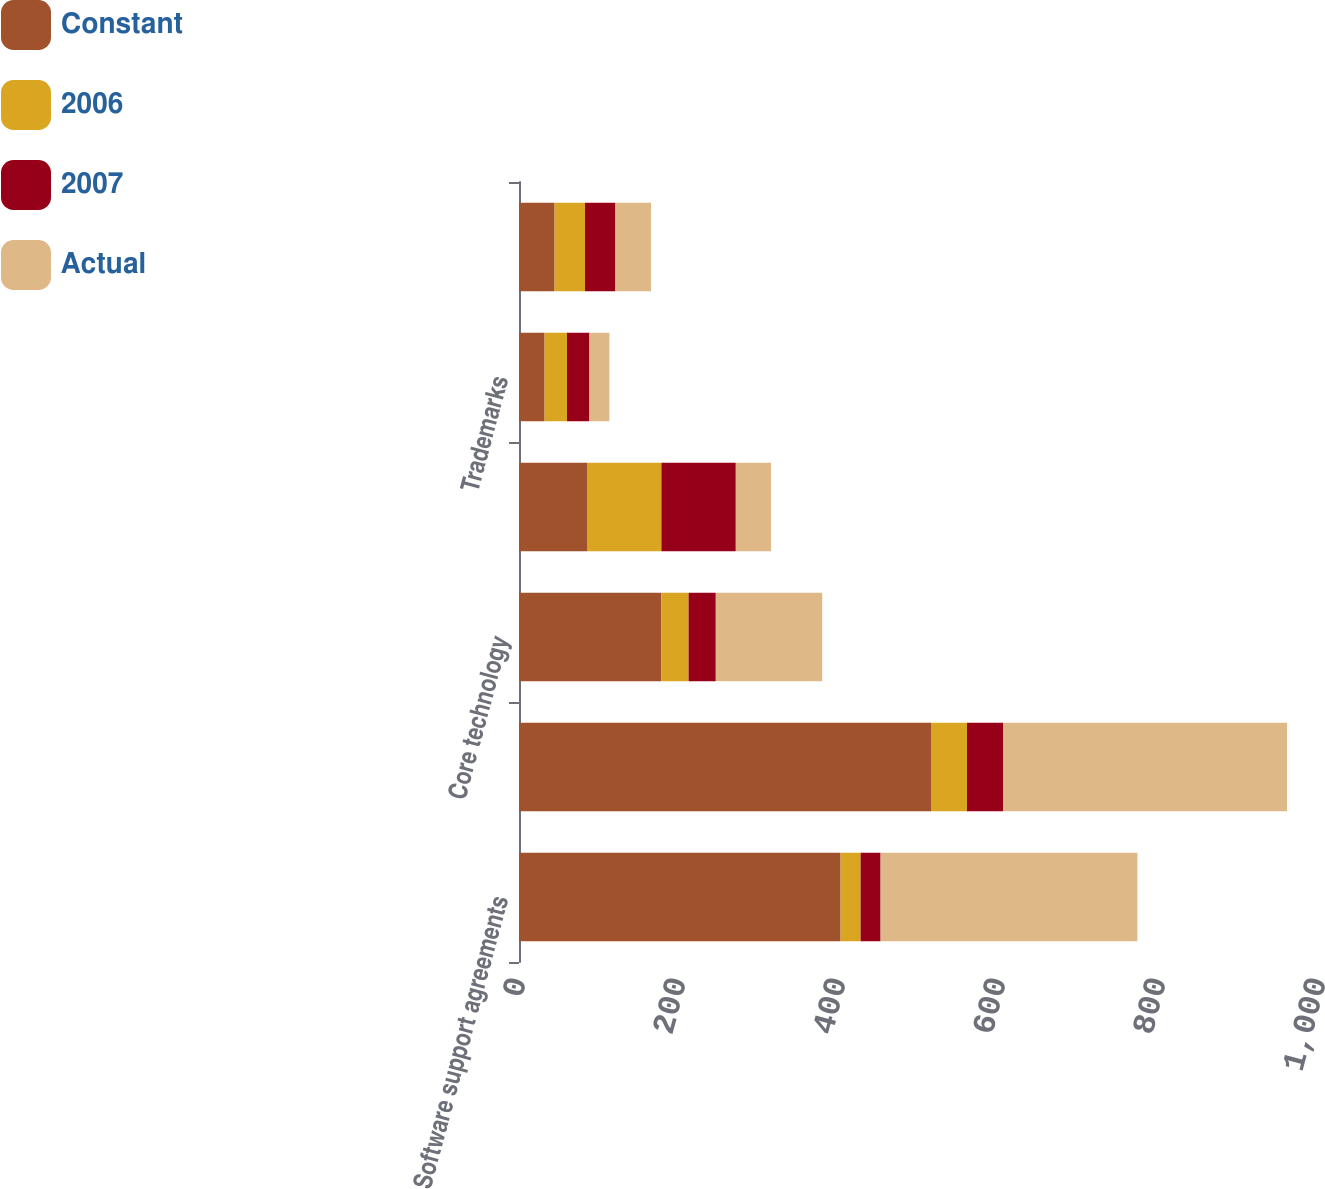Convert chart to OTSL. <chart><loc_0><loc_0><loc_500><loc_500><stacked_bar_chart><ecel><fcel>Software support agreements<fcel>Developed technology<fcel>Core technology<fcel>Customer contracts<fcel>Trademarks<fcel>Total amortization of<nl><fcel>Constant<fcel>402<fcel>515<fcel>178<fcel>85<fcel>32<fcel>44.5<nl><fcel>2006<fcel>25<fcel>45<fcel>34<fcel>93<fcel>28<fcel>38<nl><fcel>2007<fcel>25<fcel>45<fcel>34<fcel>93<fcel>28<fcel>38<nl><fcel>Actual<fcel>321<fcel>355<fcel>133<fcel>44<fcel>25<fcel>44.5<nl></chart> 